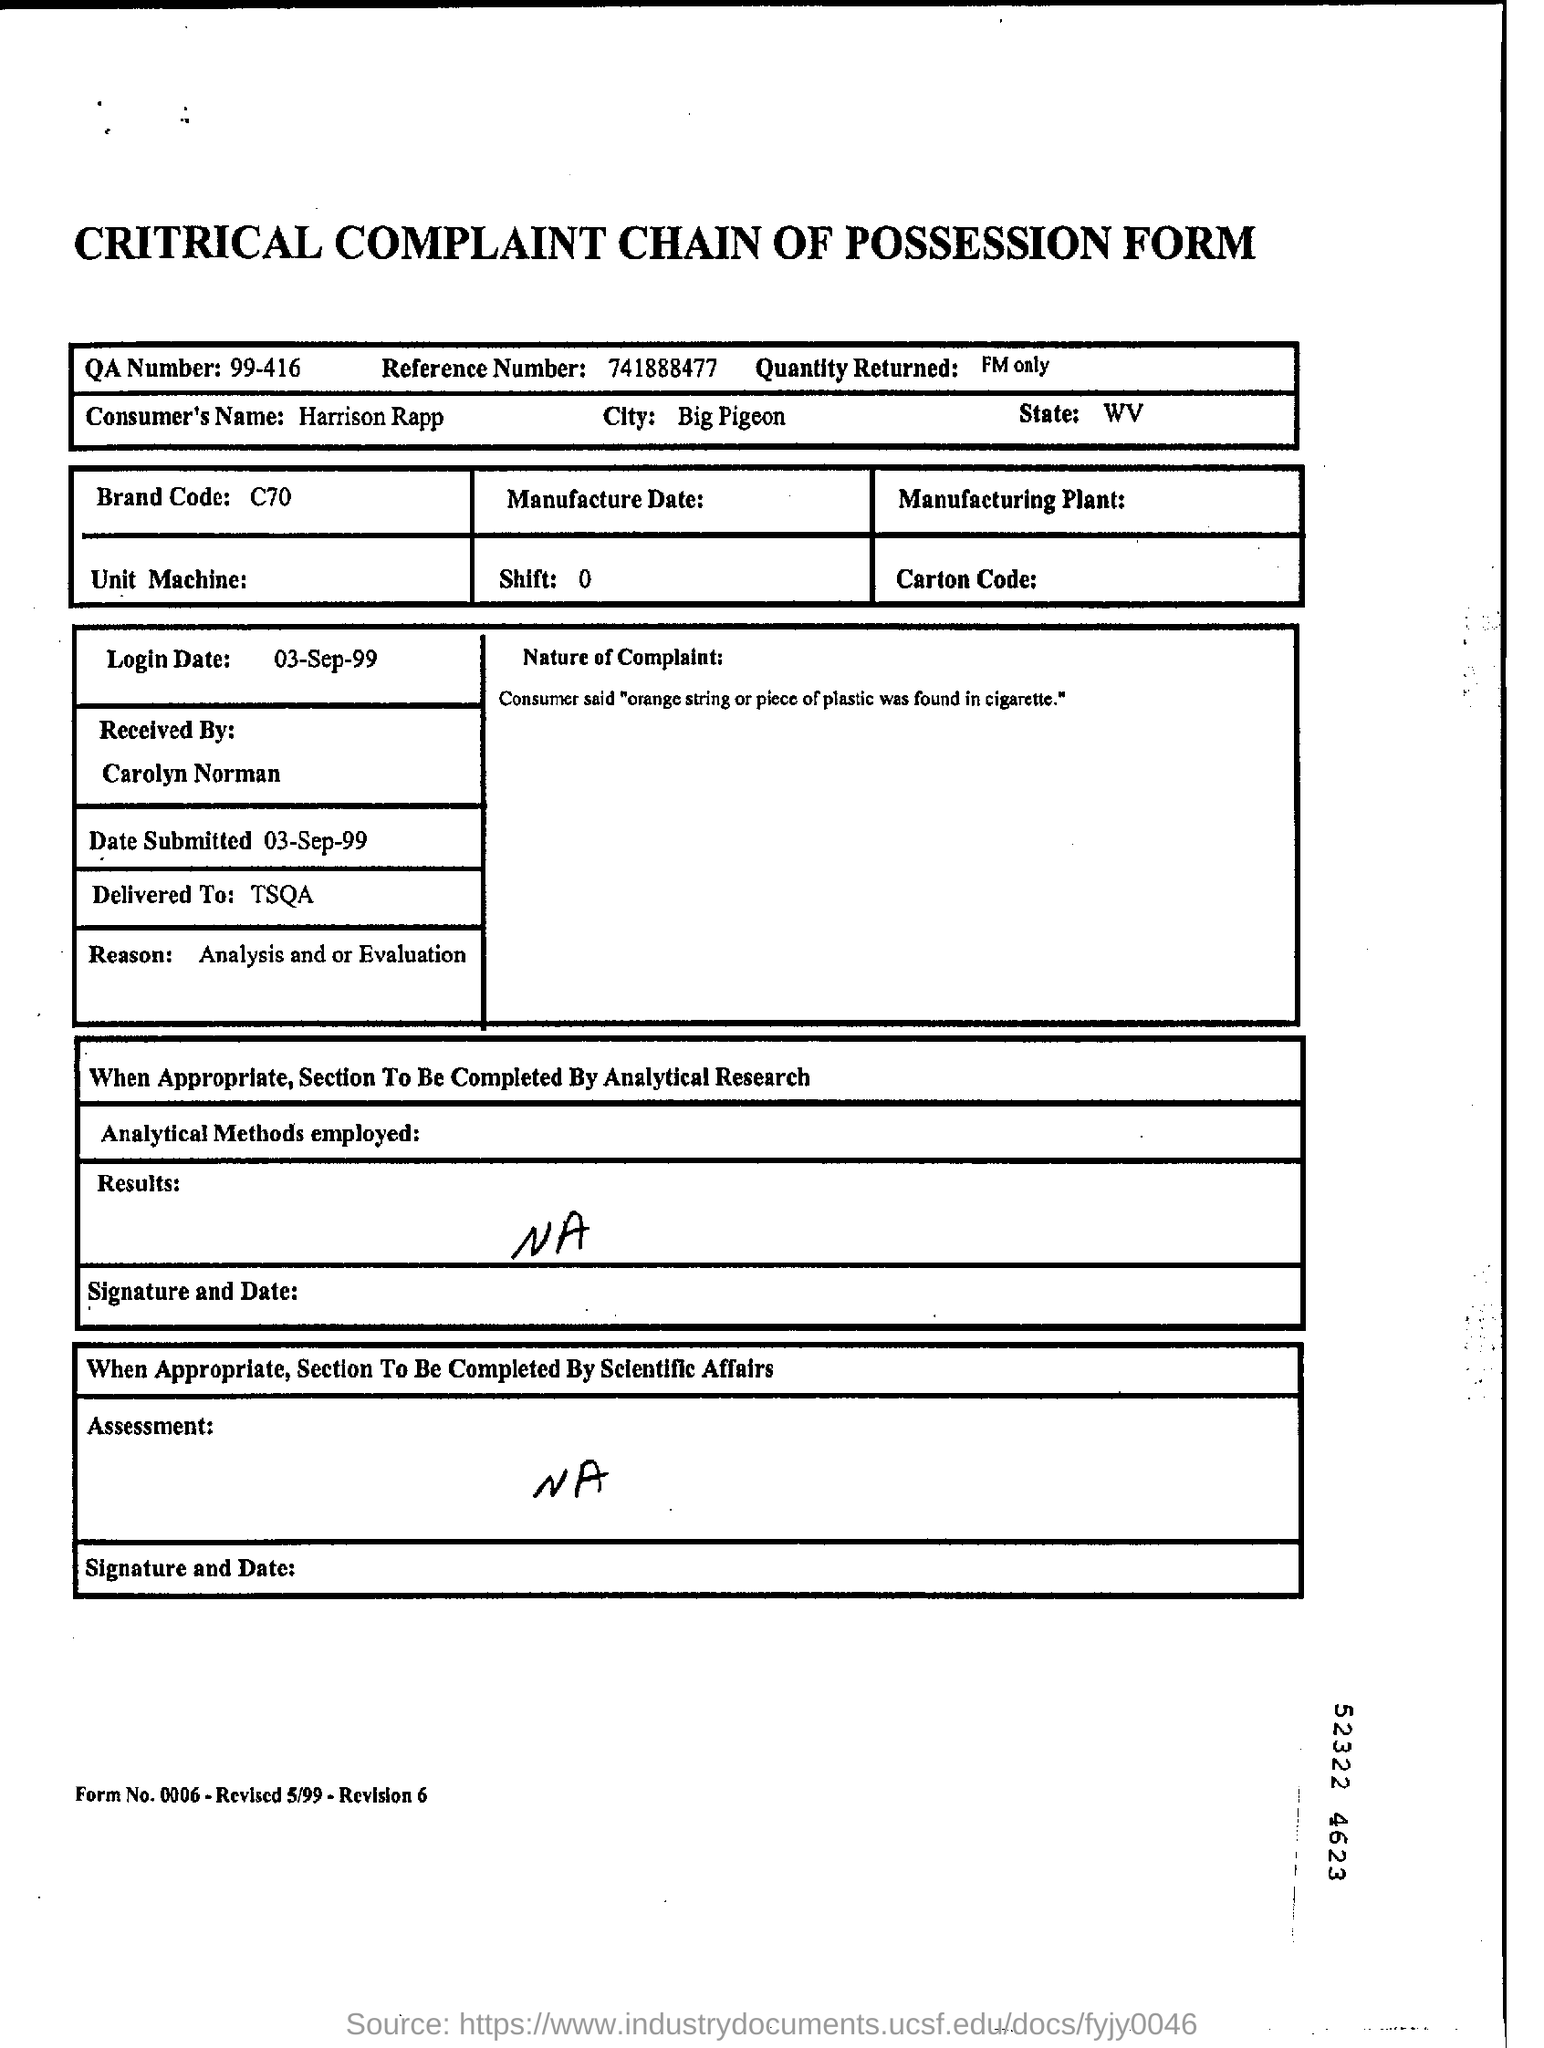What is the QA number?
Keep it short and to the point. 99-416. What is the reference number given?
Make the answer very short. 741888477. Which is the consumer's city?
Give a very brief answer. Big Pigeon. What is the brand code?
Offer a very short reply. C70. Who was it delivered to?
Your answer should be compact. TSQA. 